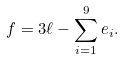Convert formula to latex. <formula><loc_0><loc_0><loc_500><loc_500>f = 3 \ell - \sum _ { i = 1 } ^ { 9 } e _ { i } .</formula> 